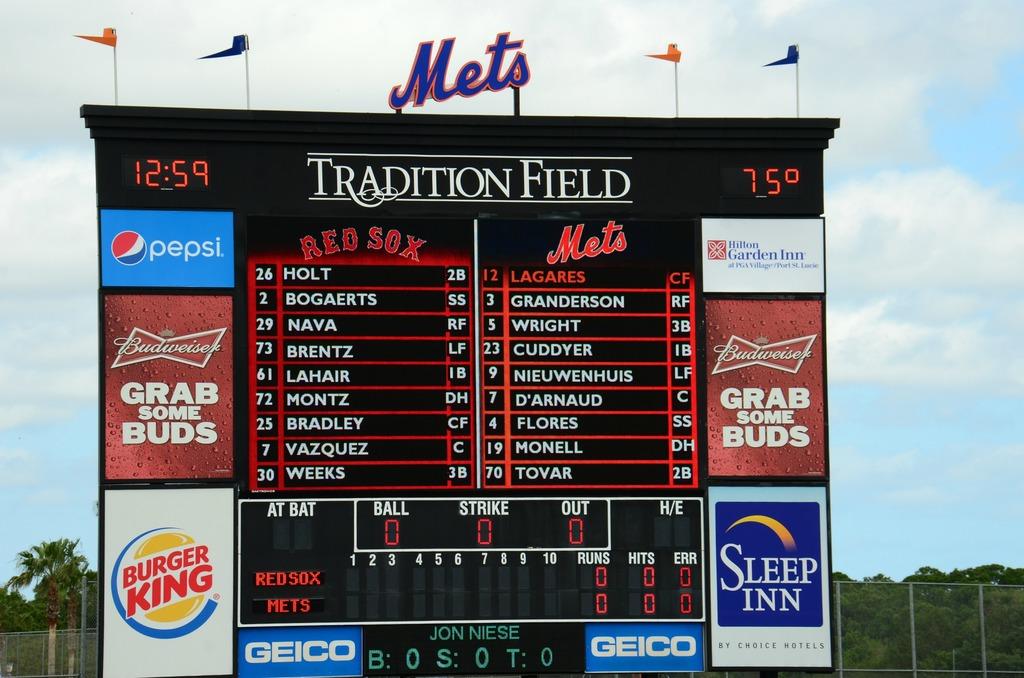What advertisement is on the bottom right?
Your answer should be very brief. Sleep inn. What time is it?
Keep it short and to the point. 12:59. 